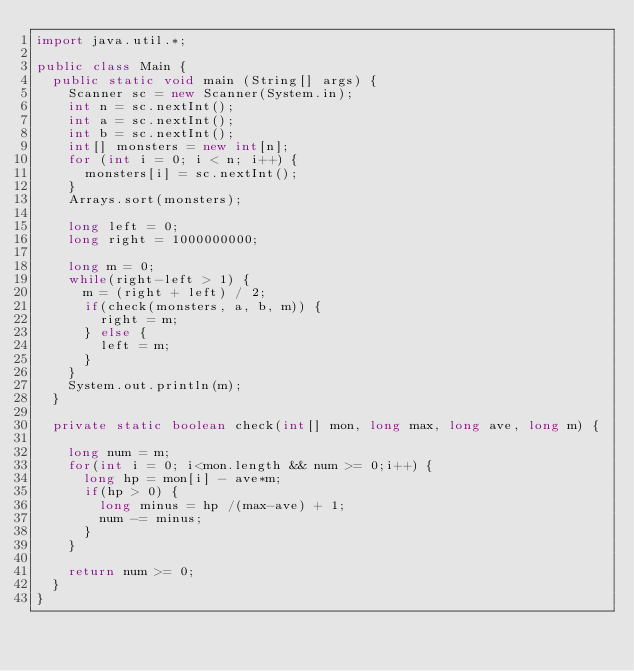Convert code to text. <code><loc_0><loc_0><loc_500><loc_500><_Java_>import java.util.*;

public class Main {
	public static void main (String[] args) {
		Scanner sc = new Scanner(System.in);
		int n = sc.nextInt();
		int a = sc.nextInt();
		int b = sc.nextInt();
		int[] monsters = new int[n];
		for (int i = 0; i < n; i++) {
			monsters[i] = sc.nextInt();
		}
		Arrays.sort(monsters);
		
		long left = 0;
		long right = 1000000000;
		
		long m = 0;
		while(right-left > 1) {
			m = (right + left) / 2;
			if(check(monsters, a, b, m)) {
				right = m;
			} else {
				left = m;
			}
		}
		System.out.println(m);
	}
	
	private static boolean check(int[] mon, long max, long ave, long m) {
		
		long num = m;
		for(int i = 0; i<mon.length && num >= 0;i++) {
			long hp = mon[i] - ave*m;
			if(hp > 0) {
				long minus = hp /(max-ave) + 1;
				num -= minus;
			}
		}
		
		return num >= 0;
	}
}</code> 